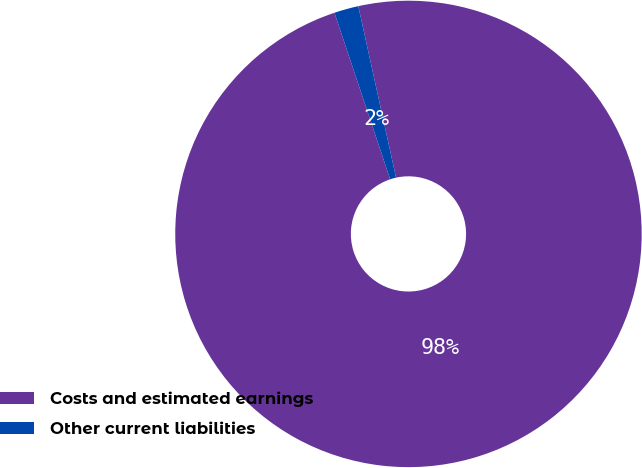<chart> <loc_0><loc_0><loc_500><loc_500><pie_chart><fcel>Costs and estimated earnings<fcel>Other current liabilities<nl><fcel>98.31%<fcel>1.69%<nl></chart> 